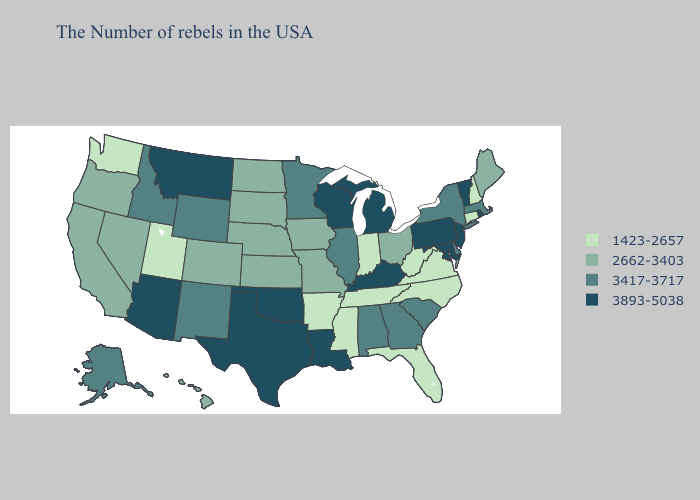Which states have the lowest value in the MidWest?
Short answer required. Indiana. Does Idaho have the lowest value in the USA?
Concise answer only. No. Among the states that border Missouri , does Iowa have the highest value?
Be succinct. No. What is the value of Utah?
Keep it brief. 1423-2657. Name the states that have a value in the range 1423-2657?
Be succinct. New Hampshire, Connecticut, Virginia, North Carolina, West Virginia, Florida, Indiana, Tennessee, Mississippi, Arkansas, Utah, Washington. What is the lowest value in the USA?
Keep it brief. 1423-2657. Which states hav the highest value in the MidWest?
Keep it brief. Michigan, Wisconsin. Does North Carolina have the lowest value in the South?
Be succinct. Yes. Name the states that have a value in the range 3893-5038?
Short answer required. Rhode Island, Vermont, New Jersey, Maryland, Pennsylvania, Michigan, Kentucky, Wisconsin, Louisiana, Oklahoma, Texas, Montana, Arizona. Name the states that have a value in the range 2662-3403?
Write a very short answer. Maine, Ohio, Missouri, Iowa, Kansas, Nebraska, South Dakota, North Dakota, Colorado, Nevada, California, Oregon, Hawaii. What is the lowest value in the USA?
Be succinct. 1423-2657. Name the states that have a value in the range 3893-5038?
Write a very short answer. Rhode Island, Vermont, New Jersey, Maryland, Pennsylvania, Michigan, Kentucky, Wisconsin, Louisiana, Oklahoma, Texas, Montana, Arizona. Among the states that border Illinois , does Missouri have the highest value?
Write a very short answer. No. Among the states that border Pennsylvania , does West Virginia have the highest value?
Give a very brief answer. No. Name the states that have a value in the range 3893-5038?
Keep it brief. Rhode Island, Vermont, New Jersey, Maryland, Pennsylvania, Michigan, Kentucky, Wisconsin, Louisiana, Oklahoma, Texas, Montana, Arizona. 